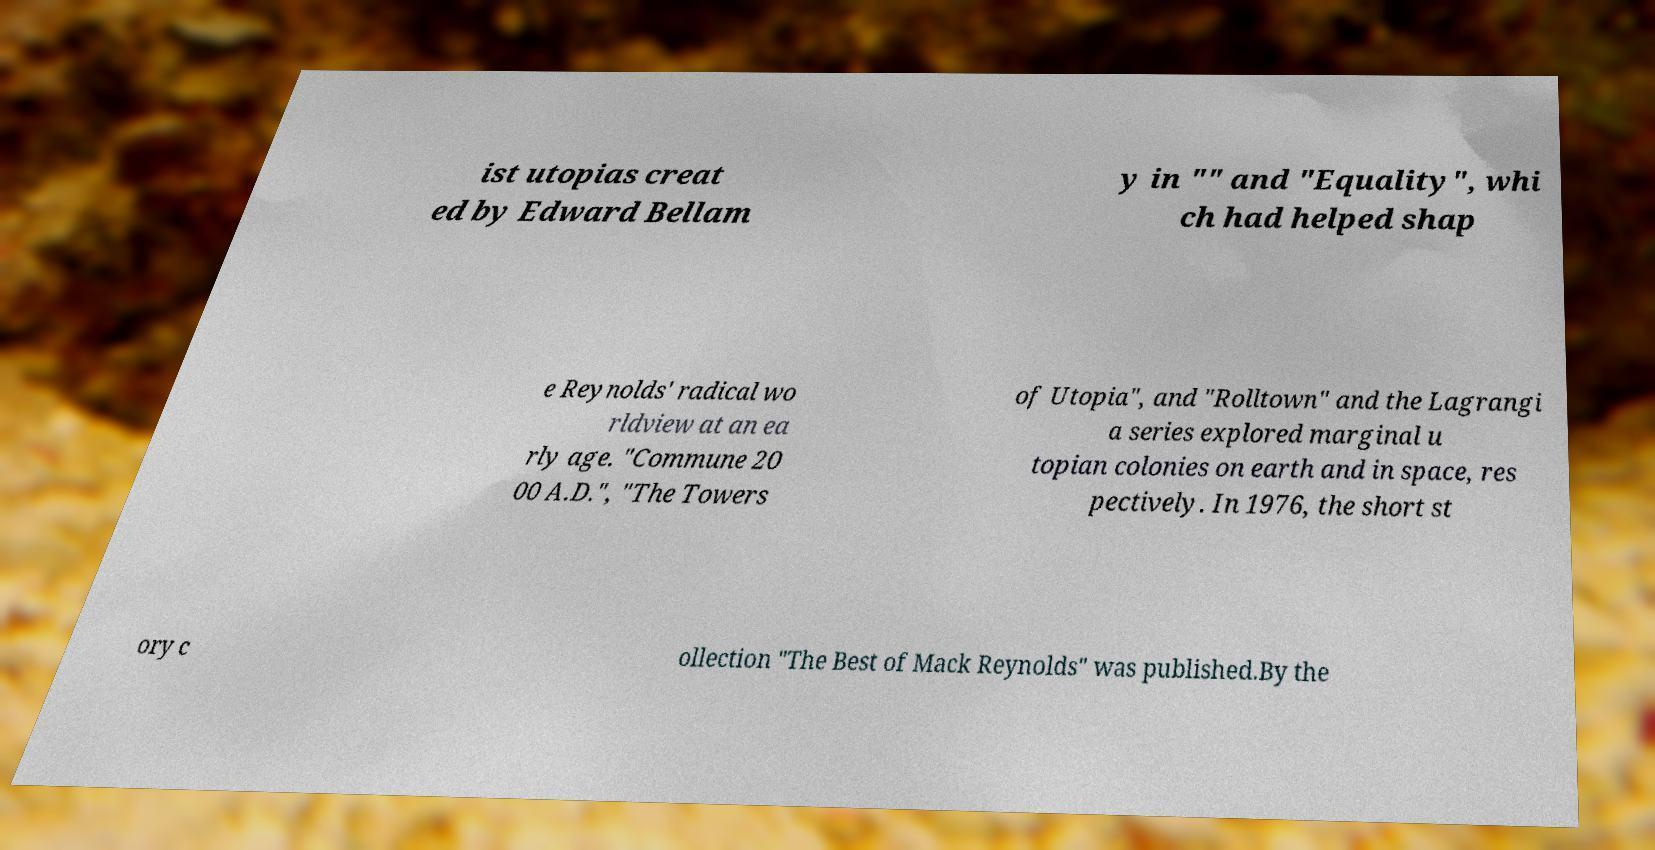Could you assist in decoding the text presented in this image and type it out clearly? ist utopias creat ed by Edward Bellam y in "" and "Equality", whi ch had helped shap e Reynolds' radical wo rldview at an ea rly age. "Commune 20 00 A.D.", "The Towers of Utopia", and "Rolltown" and the Lagrangi a series explored marginal u topian colonies on earth and in space, res pectively. In 1976, the short st ory c ollection "The Best of Mack Reynolds" was published.By the 